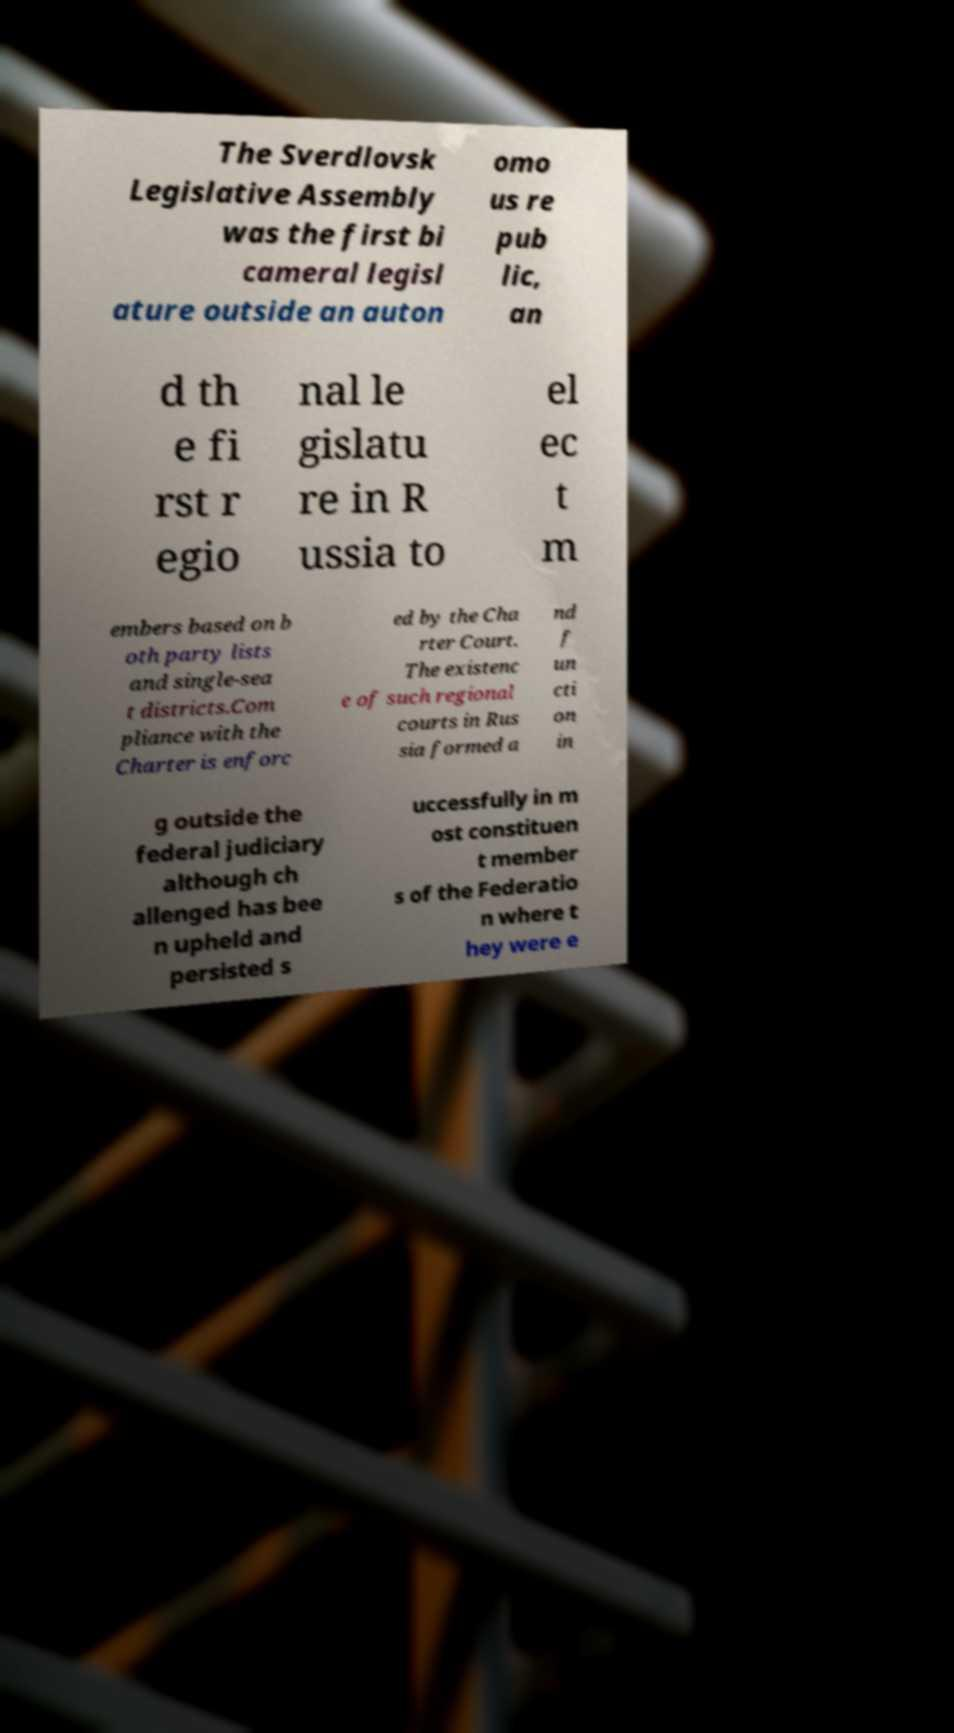Could you assist in decoding the text presented in this image and type it out clearly? The Sverdlovsk Legislative Assembly was the first bi cameral legisl ature outside an auton omo us re pub lic, an d th e fi rst r egio nal le gislatu re in R ussia to el ec t m embers based on b oth party lists and single-sea t districts.Com pliance with the Charter is enforc ed by the Cha rter Court. The existenc e of such regional courts in Rus sia formed a nd f un cti on in g outside the federal judiciary although ch allenged has bee n upheld and persisted s uccessfully in m ost constituen t member s of the Federatio n where t hey were e 